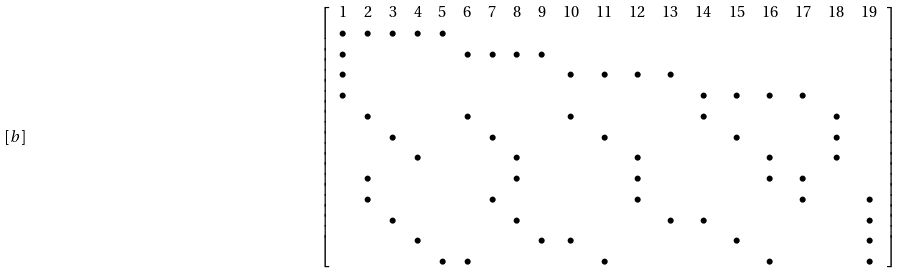Convert formula to latex. <formula><loc_0><loc_0><loc_500><loc_500>[ b ] & \quad & \left [ \begin{array} { c c c c c c c c c c c c c c c c c c c } 1 & 2 & 3 & 4 & 5 & 6 & 7 & 8 & 9 & 1 0 & 1 1 & 1 2 & 1 3 & 1 4 & 1 5 & 1 6 & 1 7 & 1 8 & 1 9 \\ \bullet & \bullet & \bullet & \bullet & \bullet & & & & & & & & & & & & & & \\ \bullet & & & & & \bullet & \bullet & \bullet & \bullet & & & & & & & & & & \\ \bullet & & & & & & & & & \bullet & \bullet & \bullet & \bullet & & & & & & \\ \bullet & & & & & & & & & & & & & \bullet & \bullet & \bullet & \bullet & & \\ & \bullet & & & & \bullet & & & & \bullet & & & & \bullet & & & & \bullet & \\ & & \bullet & & & & \bullet & & & & \bullet & & & & \bullet & & & \bullet & \\ & & & \bullet & & & & \bullet & & & & \bullet & & & & \bullet & & \bullet & \\ & \bullet & & & & & & \bullet & & & & \bullet & & & & \bullet & \bullet & \\ & \bullet & & & & & \bullet & & & & & \bullet & & & & & \bullet & & \bullet \\ & & \bullet & & & & & \bullet & & & & & \bullet & \bullet & & & & & \bullet \\ & & & \bullet & & & & & \bullet & \bullet & & & & & \bullet & & & & \bullet \\ & & & & \bullet & \bullet & & & & & \bullet & & & & & \bullet & & & \bullet \\ \end{array} \right ]</formula> 